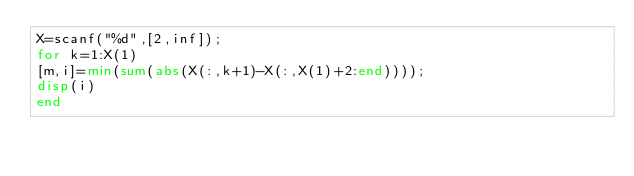Convert code to text. <code><loc_0><loc_0><loc_500><loc_500><_Octave_>X=scanf("%d",[2,inf]);
for k=1:X(1)
[m,i]=min(sum(abs(X(:,k+1)-X(:,X(1)+2:end))));
disp(i)
end</code> 